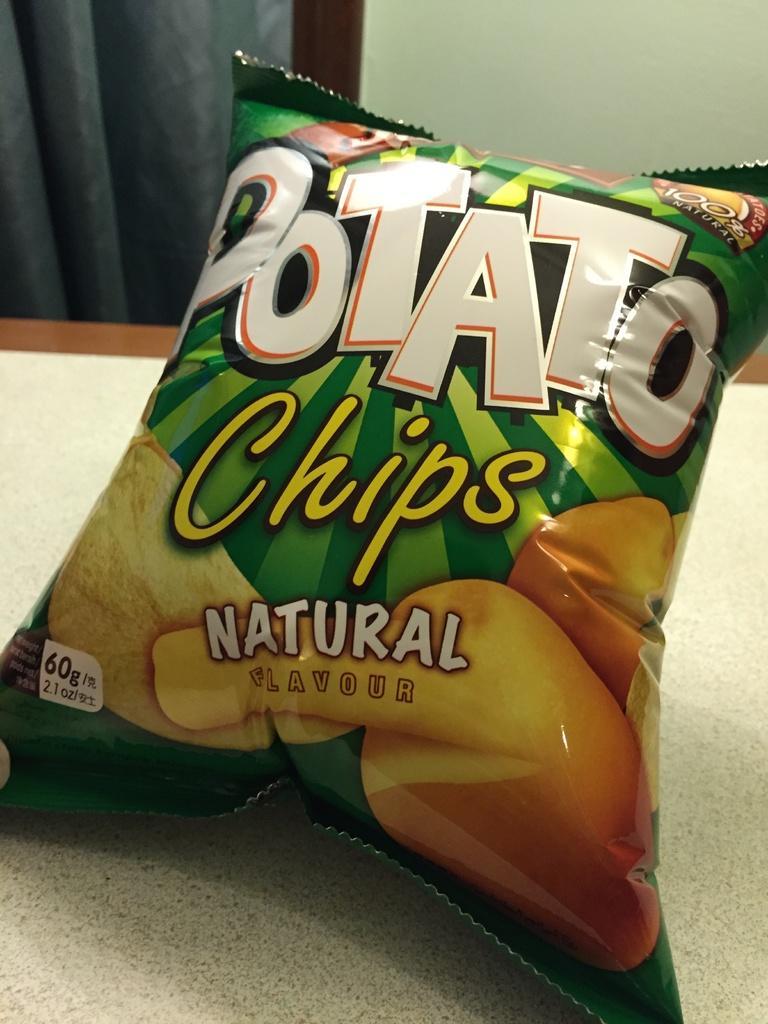Describe this image in one or two sentences. In this picture we can see a chips packet in the front, in the background there is a wall. 